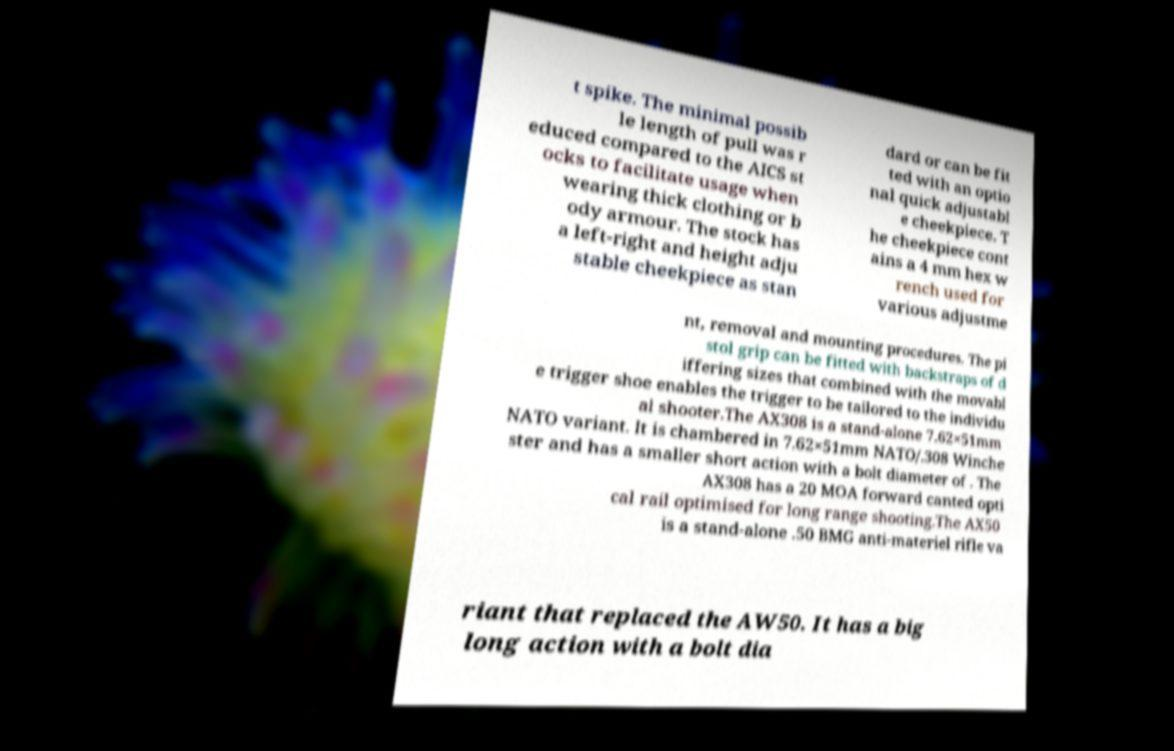For documentation purposes, I need the text within this image transcribed. Could you provide that? t spike. The minimal possib le length of pull was r educed compared to the AICS st ocks to facilitate usage when wearing thick clothing or b ody armour. The stock has a left-right and height adju stable cheekpiece as stan dard or can be fit ted with an optio nal quick adjustabl e cheekpiece. T he cheekpiece cont ains a 4 mm hex w rench used for various adjustme nt, removal and mounting procedures. The pi stol grip can be fitted with backstraps of d iffering sizes that combined with the movabl e trigger shoe enables the trigger to be tailored to the individu al shooter.The AX308 is a stand-alone 7.62×51mm NATO variant. It is chambered in 7.62×51mm NATO/.308 Winche ster and has a smaller short action with a bolt diameter of . The AX308 has a 20 MOA forward canted opti cal rail optimised for long range shooting.The AX50 is a stand-alone .50 BMG anti-materiel rifle va riant that replaced the AW50. It has a big long action with a bolt dia 